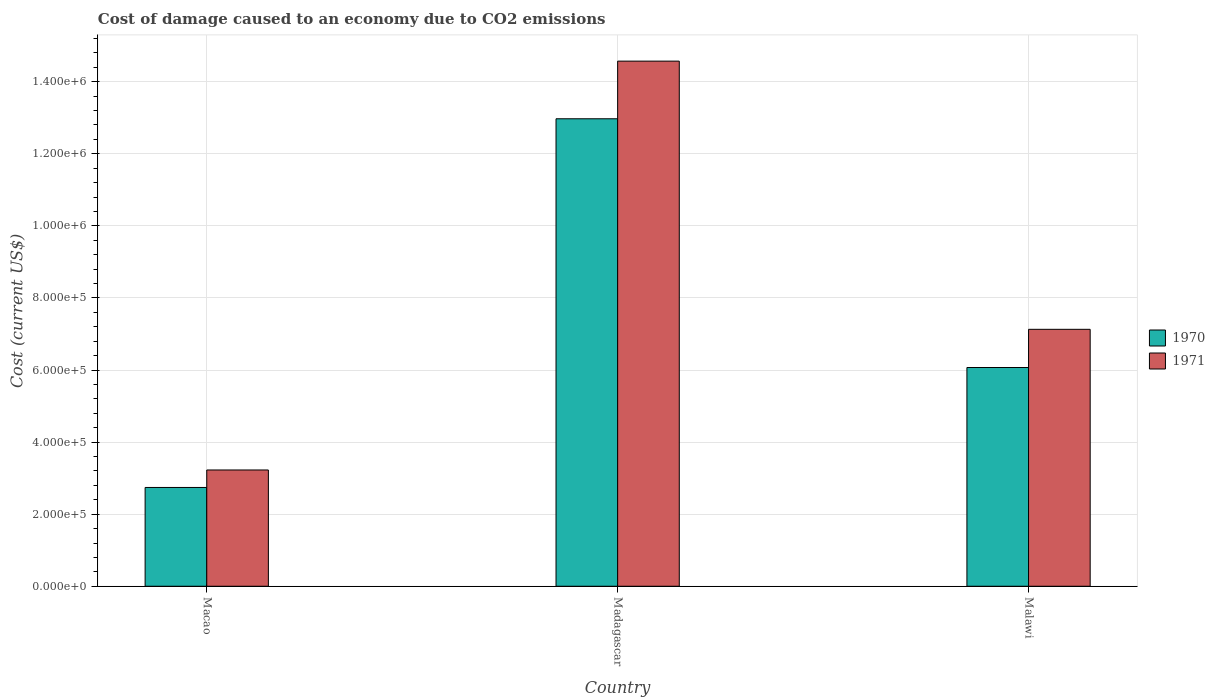How many different coloured bars are there?
Offer a very short reply. 2. Are the number of bars on each tick of the X-axis equal?
Provide a short and direct response. Yes. How many bars are there on the 1st tick from the right?
Give a very brief answer. 2. What is the label of the 3rd group of bars from the left?
Your answer should be very brief. Malawi. What is the cost of damage caused due to CO2 emissisons in 1970 in Macao?
Give a very brief answer. 2.74e+05. Across all countries, what is the maximum cost of damage caused due to CO2 emissisons in 1970?
Your answer should be very brief. 1.30e+06. Across all countries, what is the minimum cost of damage caused due to CO2 emissisons in 1970?
Your answer should be very brief. 2.74e+05. In which country was the cost of damage caused due to CO2 emissisons in 1971 maximum?
Make the answer very short. Madagascar. In which country was the cost of damage caused due to CO2 emissisons in 1971 minimum?
Offer a terse response. Macao. What is the total cost of damage caused due to CO2 emissisons in 1971 in the graph?
Your response must be concise. 2.49e+06. What is the difference between the cost of damage caused due to CO2 emissisons in 1970 in Madagascar and that in Malawi?
Your answer should be very brief. 6.90e+05. What is the difference between the cost of damage caused due to CO2 emissisons in 1971 in Macao and the cost of damage caused due to CO2 emissisons in 1970 in Madagascar?
Offer a very short reply. -9.74e+05. What is the average cost of damage caused due to CO2 emissisons in 1970 per country?
Provide a succinct answer. 7.26e+05. What is the difference between the cost of damage caused due to CO2 emissisons of/in 1970 and cost of damage caused due to CO2 emissisons of/in 1971 in Malawi?
Offer a very short reply. -1.06e+05. What is the ratio of the cost of damage caused due to CO2 emissisons in 1971 in Madagascar to that in Malawi?
Your response must be concise. 2.04. Is the cost of damage caused due to CO2 emissisons in 1970 in Macao less than that in Malawi?
Your response must be concise. Yes. What is the difference between the highest and the second highest cost of damage caused due to CO2 emissisons in 1971?
Your response must be concise. 1.13e+06. What is the difference between the highest and the lowest cost of damage caused due to CO2 emissisons in 1970?
Offer a very short reply. 1.02e+06. What does the 2nd bar from the left in Macao represents?
Keep it short and to the point. 1971. Are all the bars in the graph horizontal?
Offer a very short reply. No. Are the values on the major ticks of Y-axis written in scientific E-notation?
Keep it short and to the point. Yes. Does the graph contain grids?
Your answer should be compact. Yes. How many legend labels are there?
Offer a very short reply. 2. What is the title of the graph?
Offer a terse response. Cost of damage caused to an economy due to CO2 emissions. Does "1982" appear as one of the legend labels in the graph?
Give a very brief answer. No. What is the label or title of the X-axis?
Provide a succinct answer. Country. What is the label or title of the Y-axis?
Ensure brevity in your answer.  Cost (current US$). What is the Cost (current US$) of 1970 in Macao?
Give a very brief answer. 2.74e+05. What is the Cost (current US$) of 1971 in Macao?
Offer a terse response. 3.23e+05. What is the Cost (current US$) of 1970 in Madagascar?
Provide a short and direct response. 1.30e+06. What is the Cost (current US$) in 1971 in Madagascar?
Provide a succinct answer. 1.46e+06. What is the Cost (current US$) in 1970 in Malawi?
Your answer should be compact. 6.07e+05. What is the Cost (current US$) of 1971 in Malawi?
Ensure brevity in your answer.  7.13e+05. Across all countries, what is the maximum Cost (current US$) in 1970?
Your response must be concise. 1.30e+06. Across all countries, what is the maximum Cost (current US$) in 1971?
Ensure brevity in your answer.  1.46e+06. Across all countries, what is the minimum Cost (current US$) of 1970?
Offer a terse response. 2.74e+05. Across all countries, what is the minimum Cost (current US$) of 1971?
Offer a terse response. 3.23e+05. What is the total Cost (current US$) of 1970 in the graph?
Your answer should be compact. 2.18e+06. What is the total Cost (current US$) in 1971 in the graph?
Provide a succinct answer. 2.49e+06. What is the difference between the Cost (current US$) of 1970 in Macao and that in Madagascar?
Provide a succinct answer. -1.02e+06. What is the difference between the Cost (current US$) in 1971 in Macao and that in Madagascar?
Provide a succinct answer. -1.13e+06. What is the difference between the Cost (current US$) in 1970 in Macao and that in Malawi?
Your answer should be compact. -3.33e+05. What is the difference between the Cost (current US$) in 1971 in Macao and that in Malawi?
Your response must be concise. -3.90e+05. What is the difference between the Cost (current US$) in 1970 in Madagascar and that in Malawi?
Your response must be concise. 6.90e+05. What is the difference between the Cost (current US$) in 1971 in Madagascar and that in Malawi?
Provide a succinct answer. 7.44e+05. What is the difference between the Cost (current US$) of 1970 in Macao and the Cost (current US$) of 1971 in Madagascar?
Keep it short and to the point. -1.18e+06. What is the difference between the Cost (current US$) of 1970 in Macao and the Cost (current US$) of 1971 in Malawi?
Your answer should be very brief. -4.39e+05. What is the difference between the Cost (current US$) of 1970 in Madagascar and the Cost (current US$) of 1971 in Malawi?
Give a very brief answer. 5.84e+05. What is the average Cost (current US$) of 1970 per country?
Make the answer very short. 7.26e+05. What is the average Cost (current US$) of 1971 per country?
Offer a terse response. 8.31e+05. What is the difference between the Cost (current US$) of 1970 and Cost (current US$) of 1971 in Macao?
Provide a short and direct response. -4.85e+04. What is the difference between the Cost (current US$) in 1970 and Cost (current US$) in 1971 in Madagascar?
Ensure brevity in your answer.  -1.60e+05. What is the difference between the Cost (current US$) of 1970 and Cost (current US$) of 1971 in Malawi?
Offer a very short reply. -1.06e+05. What is the ratio of the Cost (current US$) in 1970 in Macao to that in Madagascar?
Provide a short and direct response. 0.21. What is the ratio of the Cost (current US$) of 1971 in Macao to that in Madagascar?
Keep it short and to the point. 0.22. What is the ratio of the Cost (current US$) of 1970 in Macao to that in Malawi?
Your answer should be compact. 0.45. What is the ratio of the Cost (current US$) in 1971 in Macao to that in Malawi?
Give a very brief answer. 0.45. What is the ratio of the Cost (current US$) in 1970 in Madagascar to that in Malawi?
Your response must be concise. 2.14. What is the ratio of the Cost (current US$) in 1971 in Madagascar to that in Malawi?
Your answer should be compact. 2.04. What is the difference between the highest and the second highest Cost (current US$) of 1970?
Provide a short and direct response. 6.90e+05. What is the difference between the highest and the second highest Cost (current US$) in 1971?
Provide a succinct answer. 7.44e+05. What is the difference between the highest and the lowest Cost (current US$) of 1970?
Provide a short and direct response. 1.02e+06. What is the difference between the highest and the lowest Cost (current US$) of 1971?
Provide a short and direct response. 1.13e+06. 